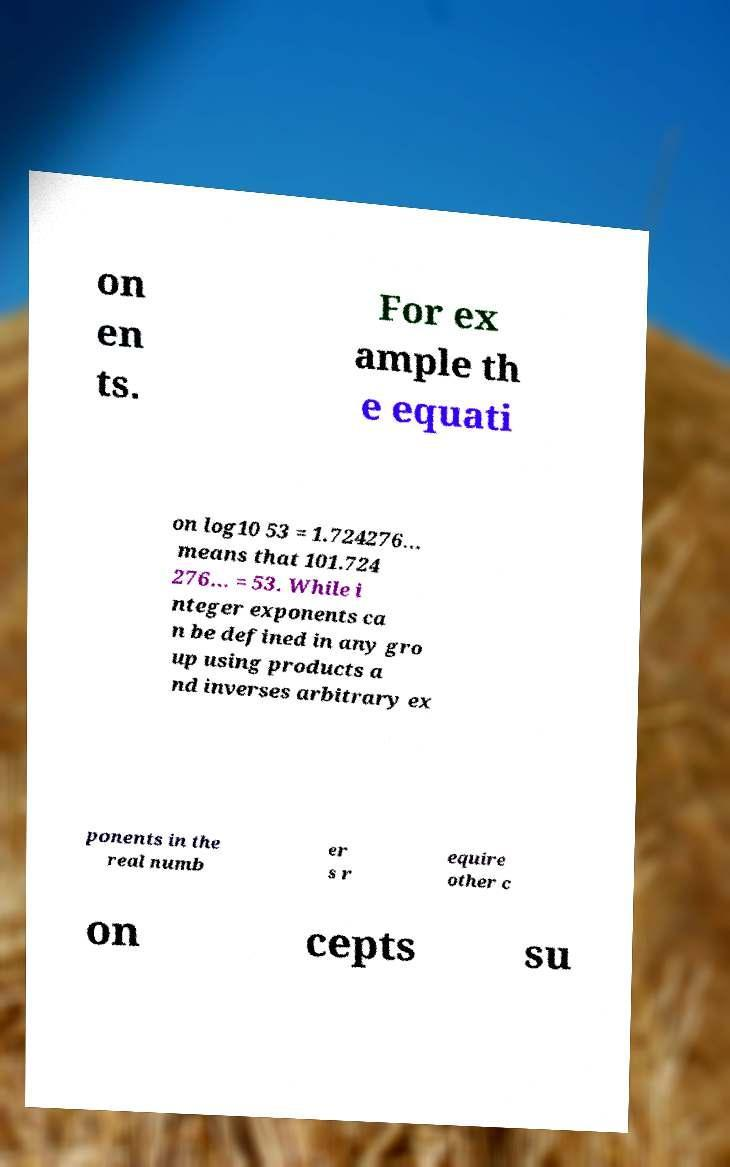There's text embedded in this image that I need extracted. Can you transcribe it verbatim? on en ts. For ex ample th e equati on log10 53 = 1.724276… means that 101.724 276… = 53. While i nteger exponents ca n be defined in any gro up using products a nd inverses arbitrary ex ponents in the real numb er s r equire other c on cepts su 